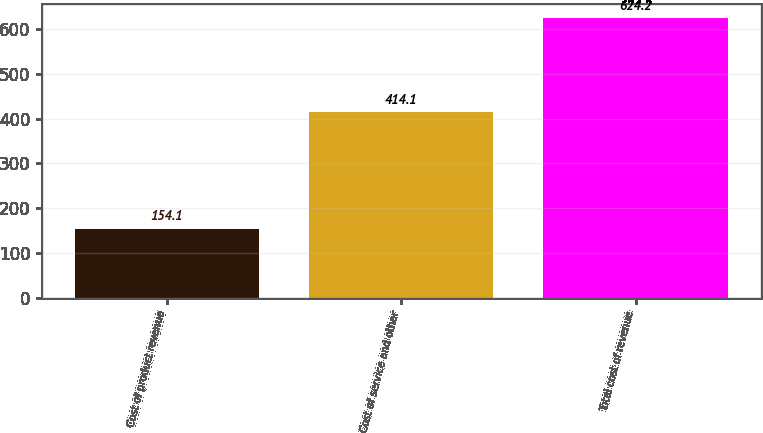<chart> <loc_0><loc_0><loc_500><loc_500><bar_chart><fcel>Cost of product revenue<fcel>Cost of service and other<fcel>Total cost of revenue<nl><fcel>154.1<fcel>414.1<fcel>624.2<nl></chart> 